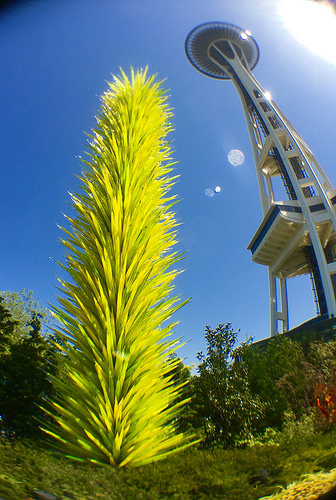<image>
Can you confirm if the plant is above the land? No. The plant is not positioned above the land. The vertical arrangement shows a different relationship. 